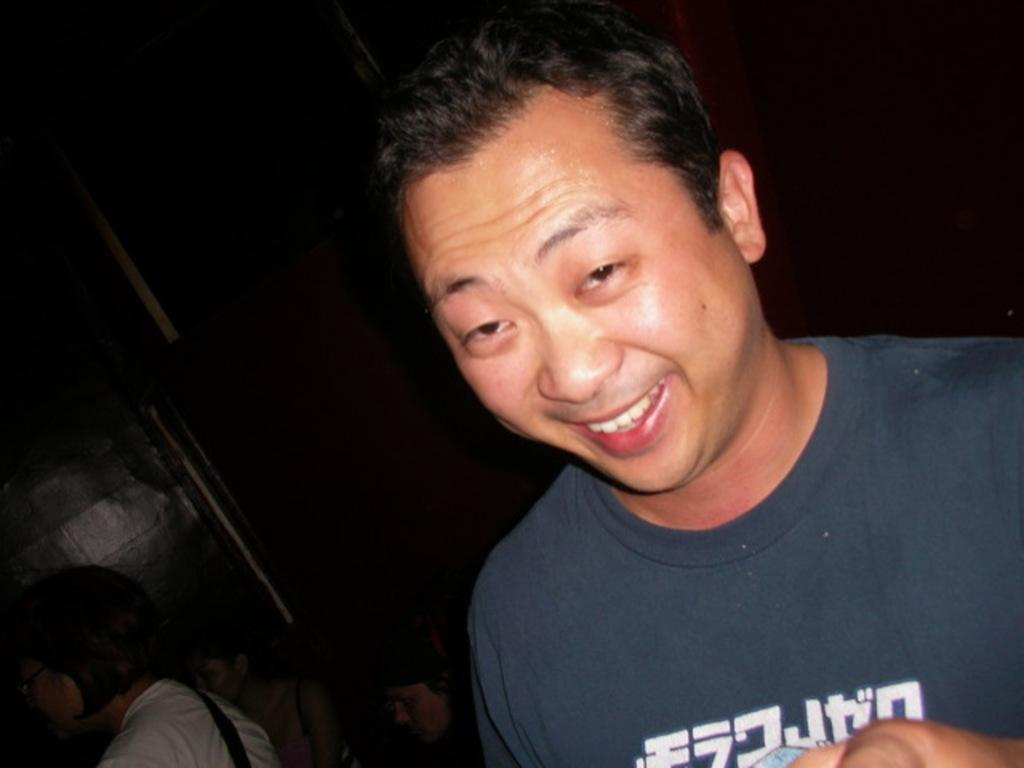What is the person in the image wearing? The person is wearing a navy-blue t-shirt in the image. What colors can be seen in the background of the image? The background of the image is in black and brown colors. How many people are visible in the image? There are people visible in the image. What type of button can be seen on the scale in the image? There is no button or scale present in the image. What is the mass of the object on the scale in the image? There is no object on a scale in the image, so it is not possible to determine its mass. 